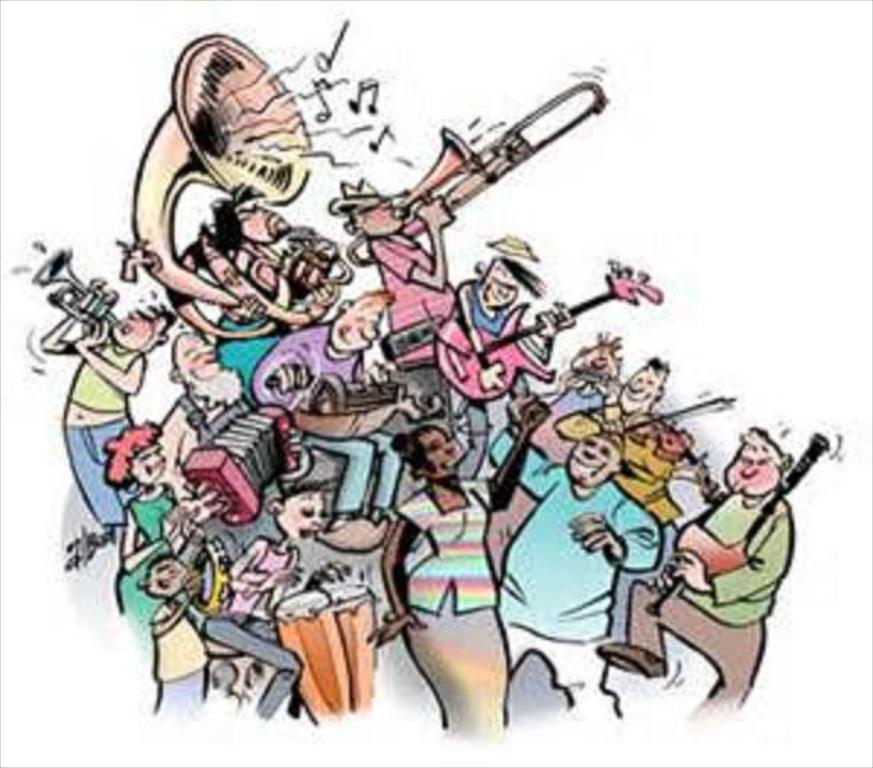What type of artwork is depicted in the image? The image is a painting. What can be seen in the painting? There are persons and musical instruments in the painting. What type of quartz is used to create the musical instruments in the painting? There is no mention of quartz or any specific materials used to create the musical instruments in the painting. 